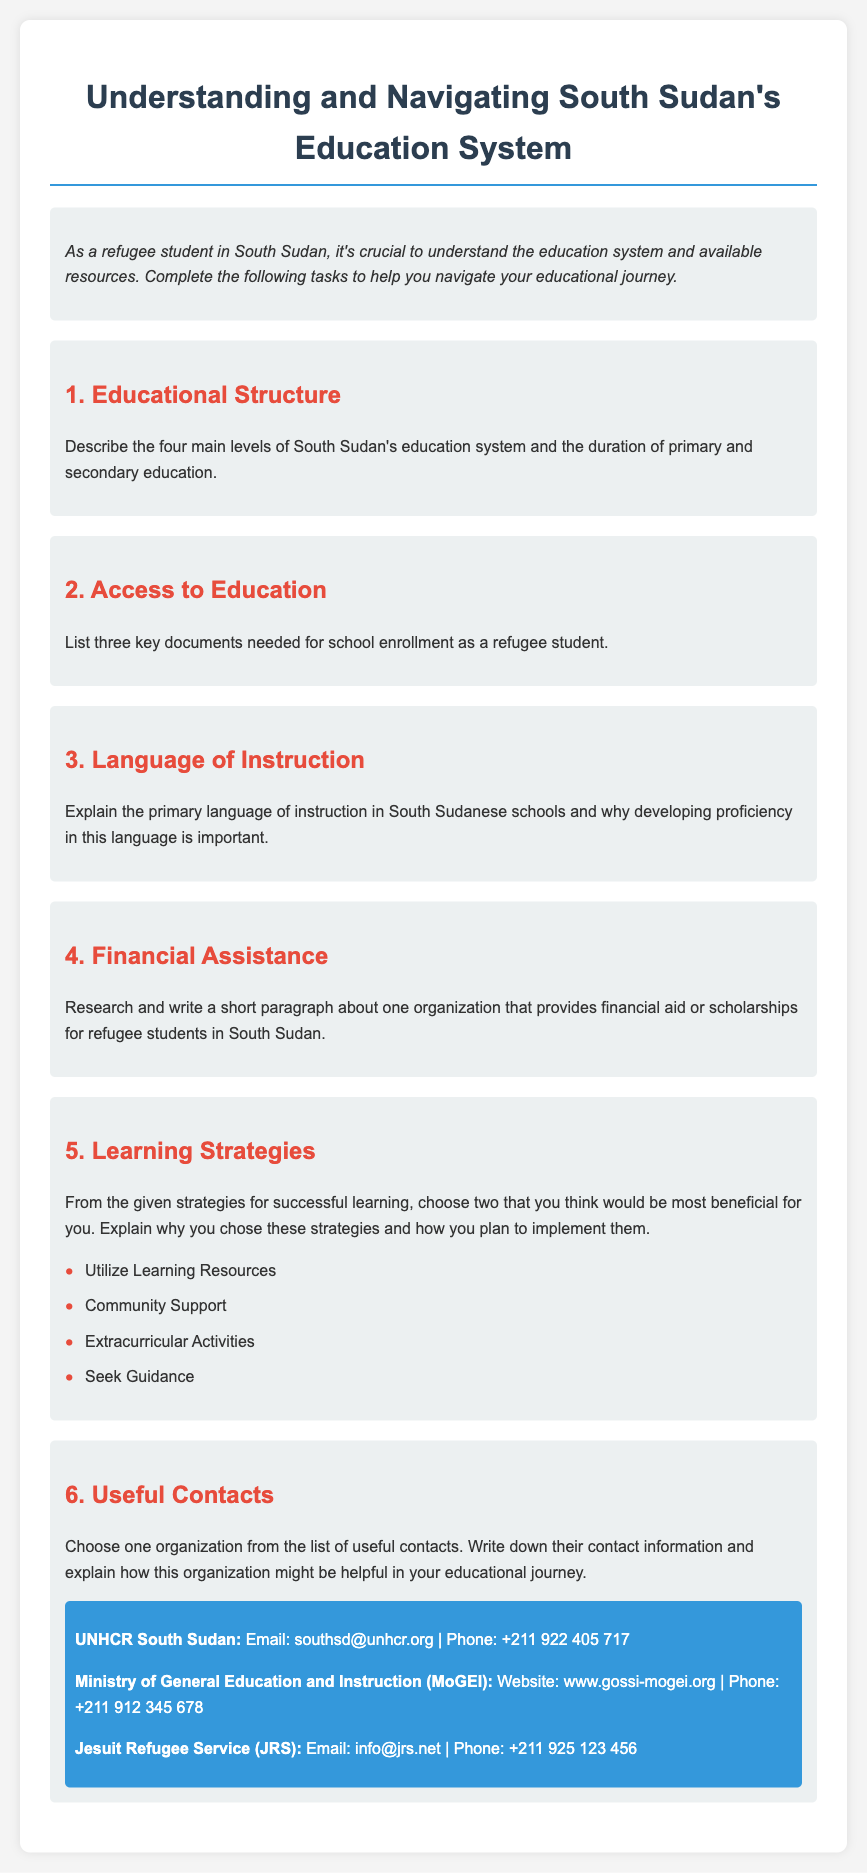What are the four main levels of South Sudan's education system? The document states there are four main levels, which are not specifically listed but are implied to be described in the educational structure section.
Answer: Not specified What is the duration of primary education in South Sudan? The document mentions the duration of primary education, but this information is not explicitly provided in the text.
Answer: Not specified Name one organization that provides financial aid for refugee students in South Sudan. The financial assistance section prompts the reader to research, and one organization that is likely included is not specified in the document.
Answer: Not specified What is one key document needed for school enrollment as a refugee student? The document specifies that three key documents are needed, highlighting the need for enrollment but does not detail any document.
Answer: Not specified What is the primary language of instruction in South Sudanese schools? The document discusses the importance of the primary language but does not explicitly provide its name within the text.
Answer: Not specified List two learning strategies mentioned in the document. The document provides a list of learning strategies under the Learning Strategies section.
Answer: Utilize Learning Resources, Community Support What is the email address of UNHCR South Sudan? The document lists contact information, and the email is provided under the useful contacts section.
Answer: southsd@unhcr.org What is the phone number for the Ministry of General Education and Instruction (MoGEI)? The contact information section includes the phone number for MoGEI.
Answer: +211 912 345 678 